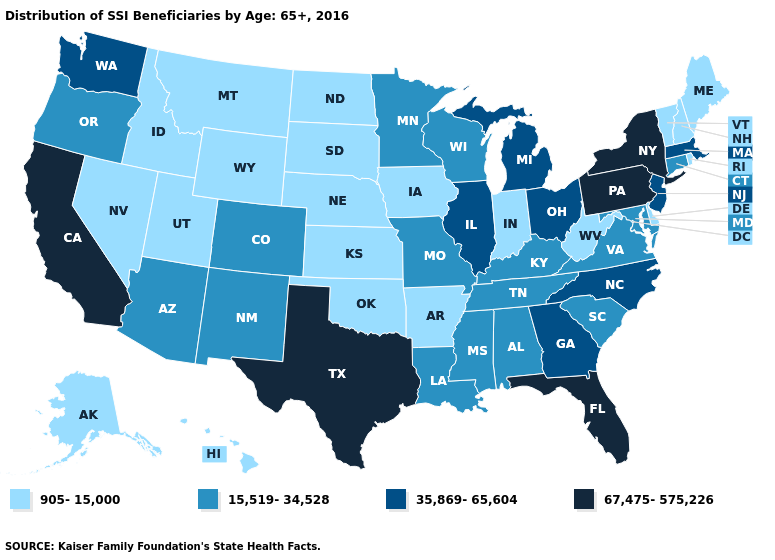Is the legend a continuous bar?
Be succinct. No. What is the value of Massachusetts?
Give a very brief answer. 35,869-65,604. Name the states that have a value in the range 35,869-65,604?
Concise answer only. Georgia, Illinois, Massachusetts, Michigan, New Jersey, North Carolina, Ohio, Washington. Does Utah have a higher value than Florida?
Be succinct. No. Among the states that border Delaware , does Pennsylvania have the highest value?
Quick response, please. Yes. Name the states that have a value in the range 905-15,000?
Answer briefly. Alaska, Arkansas, Delaware, Hawaii, Idaho, Indiana, Iowa, Kansas, Maine, Montana, Nebraska, Nevada, New Hampshire, North Dakota, Oklahoma, Rhode Island, South Dakota, Utah, Vermont, West Virginia, Wyoming. Name the states that have a value in the range 35,869-65,604?
Answer briefly. Georgia, Illinois, Massachusetts, Michigan, New Jersey, North Carolina, Ohio, Washington. Does Wyoming have a higher value than Michigan?
Concise answer only. No. What is the value of Connecticut?
Short answer required. 15,519-34,528. Does Florida have a higher value than Texas?
Give a very brief answer. No. Does Louisiana have a higher value than Iowa?
Answer briefly. Yes. Name the states that have a value in the range 15,519-34,528?
Give a very brief answer. Alabama, Arizona, Colorado, Connecticut, Kentucky, Louisiana, Maryland, Minnesota, Mississippi, Missouri, New Mexico, Oregon, South Carolina, Tennessee, Virginia, Wisconsin. Name the states that have a value in the range 67,475-575,226?
Quick response, please. California, Florida, New York, Pennsylvania, Texas. What is the lowest value in the USA?
Keep it brief. 905-15,000. Does Ohio have a higher value than California?
Concise answer only. No. 